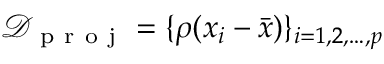Convert formula to latex. <formula><loc_0><loc_0><loc_500><loc_500>\mathcal { D } _ { p r o j } = \{ \rho ( x _ { i } - \bar { x } ) \} _ { i = 1 , 2 , \dots , p }</formula> 